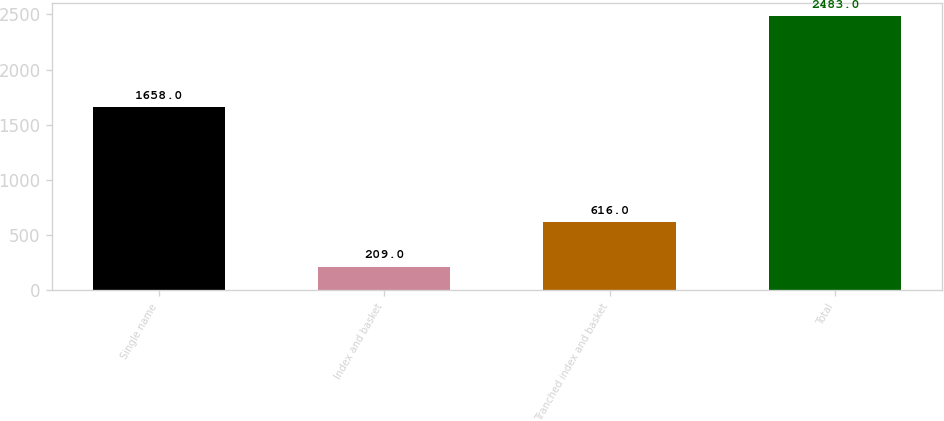<chart> <loc_0><loc_0><loc_500><loc_500><bar_chart><fcel>Single name<fcel>Index and basket<fcel>Tranched index and basket<fcel>Total<nl><fcel>1658<fcel>209<fcel>616<fcel>2483<nl></chart> 